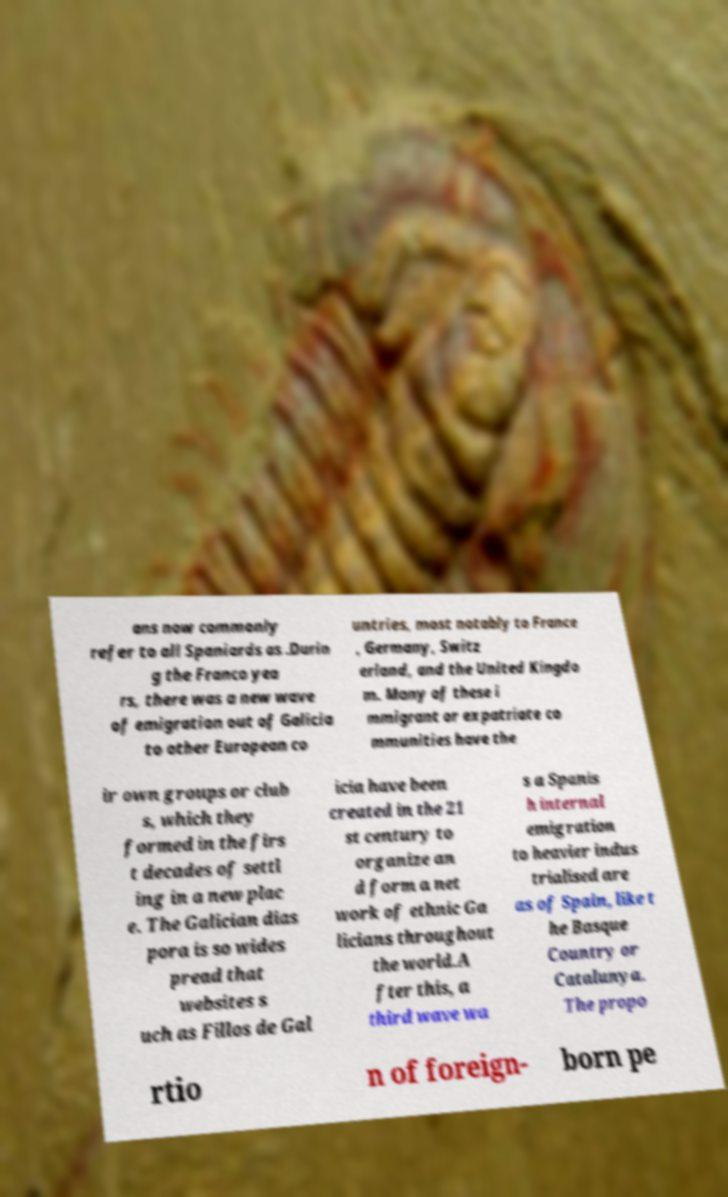Please identify and transcribe the text found in this image. ans now commonly refer to all Spaniards as .Durin g the Franco yea rs, there was a new wave of emigration out of Galicia to other European co untries, most notably to France , Germany, Switz erland, and the United Kingdo m. Many of these i mmigrant or expatriate co mmunities have the ir own groups or club s, which they formed in the firs t decades of settl ing in a new plac e. The Galician dias pora is so wides pread that websites s uch as Fillos de Gal icia have been created in the 21 st century to organize an d form a net work of ethnic Ga licians throughout the world.A fter this, a third wave wa s a Spanis h internal emigration to heavier indus trialised are as of Spain, like t he Basque Country or Catalunya. The propo rtio n of foreign- born pe 